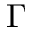Convert formula to latex. <formula><loc_0><loc_0><loc_500><loc_500>\Gamma</formula> 